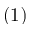<formula> <loc_0><loc_0><loc_500><loc_500>( 1 )</formula> 